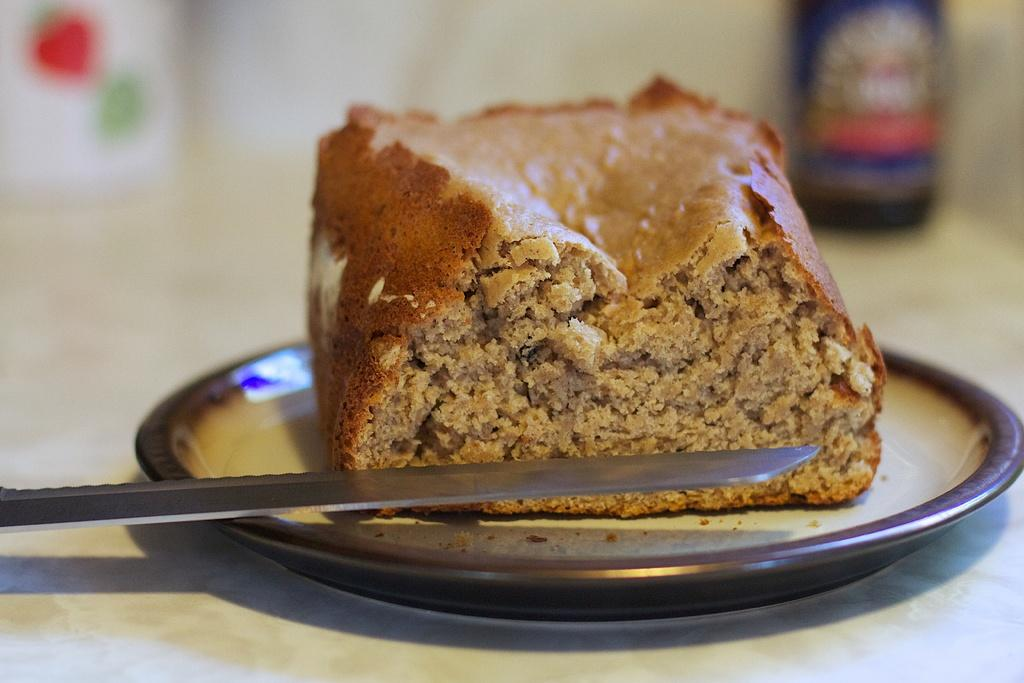What is the main object in the foreground of the image? There is a bread on a platter in the foreground of the image. What is placed on the bread? There is a knife on the bread. What can be seen in the background of the image? In the background, there is a bottle. Can you describe the objects in the background in more detail? Unfortunately, the remaining objects in the background are not clear. What type of flag is being waved by the maid in the image? There is no flag or maid present in the image. 